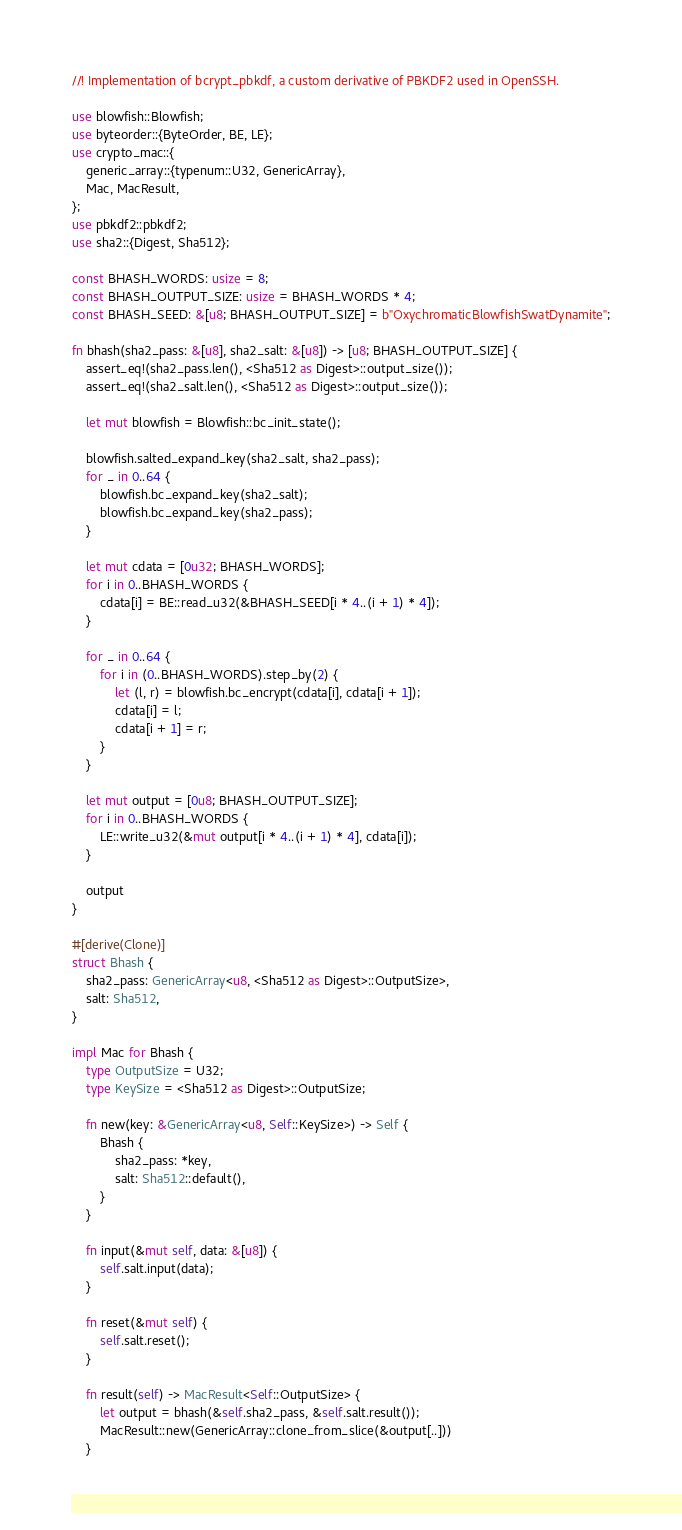Convert code to text. <code><loc_0><loc_0><loc_500><loc_500><_Rust_>//! Implementation of bcrypt_pbkdf, a custom derivative of PBKDF2 used in OpenSSH.

use blowfish::Blowfish;
use byteorder::{ByteOrder, BE, LE};
use crypto_mac::{
    generic_array::{typenum::U32, GenericArray},
    Mac, MacResult,
};
use pbkdf2::pbkdf2;
use sha2::{Digest, Sha512};

const BHASH_WORDS: usize = 8;
const BHASH_OUTPUT_SIZE: usize = BHASH_WORDS * 4;
const BHASH_SEED: &[u8; BHASH_OUTPUT_SIZE] = b"OxychromaticBlowfishSwatDynamite";

fn bhash(sha2_pass: &[u8], sha2_salt: &[u8]) -> [u8; BHASH_OUTPUT_SIZE] {
    assert_eq!(sha2_pass.len(), <Sha512 as Digest>::output_size());
    assert_eq!(sha2_salt.len(), <Sha512 as Digest>::output_size());

    let mut blowfish = Blowfish::bc_init_state();

    blowfish.salted_expand_key(sha2_salt, sha2_pass);
    for _ in 0..64 {
        blowfish.bc_expand_key(sha2_salt);
        blowfish.bc_expand_key(sha2_pass);
    }

    let mut cdata = [0u32; BHASH_WORDS];
    for i in 0..BHASH_WORDS {
        cdata[i] = BE::read_u32(&BHASH_SEED[i * 4..(i + 1) * 4]);
    }

    for _ in 0..64 {
        for i in (0..BHASH_WORDS).step_by(2) {
            let (l, r) = blowfish.bc_encrypt(cdata[i], cdata[i + 1]);
            cdata[i] = l;
            cdata[i + 1] = r;
        }
    }

    let mut output = [0u8; BHASH_OUTPUT_SIZE];
    for i in 0..BHASH_WORDS {
        LE::write_u32(&mut output[i * 4..(i + 1) * 4], cdata[i]);
    }

    output
}

#[derive(Clone)]
struct Bhash {
    sha2_pass: GenericArray<u8, <Sha512 as Digest>::OutputSize>,
    salt: Sha512,
}

impl Mac for Bhash {
    type OutputSize = U32;
    type KeySize = <Sha512 as Digest>::OutputSize;

    fn new(key: &GenericArray<u8, Self::KeySize>) -> Self {
        Bhash {
            sha2_pass: *key,
            salt: Sha512::default(),
        }
    }

    fn input(&mut self, data: &[u8]) {
        self.salt.input(data);
    }

    fn reset(&mut self) {
        self.salt.reset();
    }

    fn result(self) -> MacResult<Self::OutputSize> {
        let output = bhash(&self.sha2_pass, &self.salt.result());
        MacResult::new(GenericArray::clone_from_slice(&output[..]))
    }</code> 